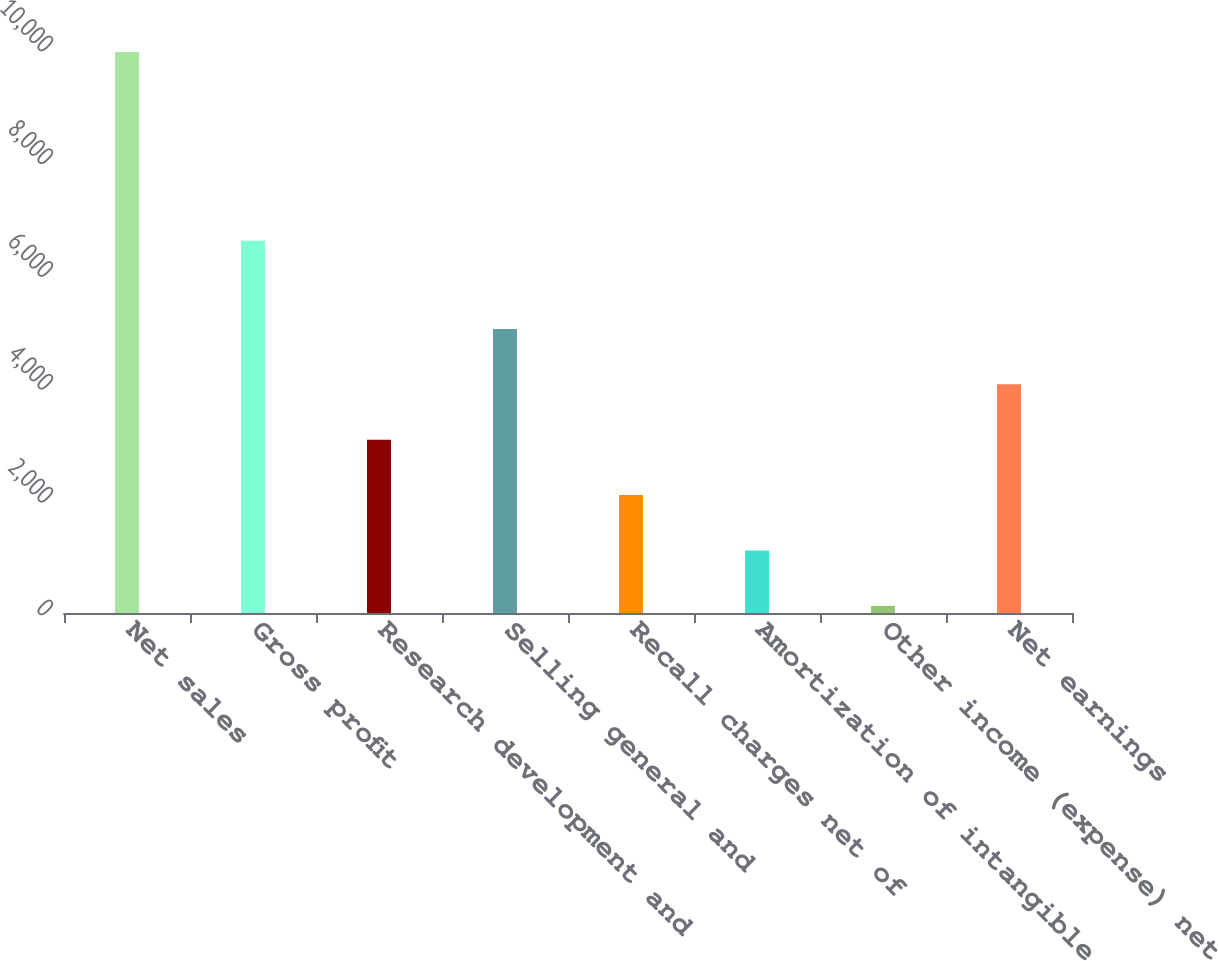<chart> <loc_0><loc_0><loc_500><loc_500><bar_chart><fcel>Net sales<fcel>Gross profit<fcel>Research development and<fcel>Selling general and<fcel>Recall charges net of<fcel>Amortization of intangible<fcel>Other income (expense) net<fcel>Net earnings<nl><fcel>9946<fcel>6602<fcel>3072<fcel>5036<fcel>2090<fcel>1108<fcel>126<fcel>4054<nl></chart> 